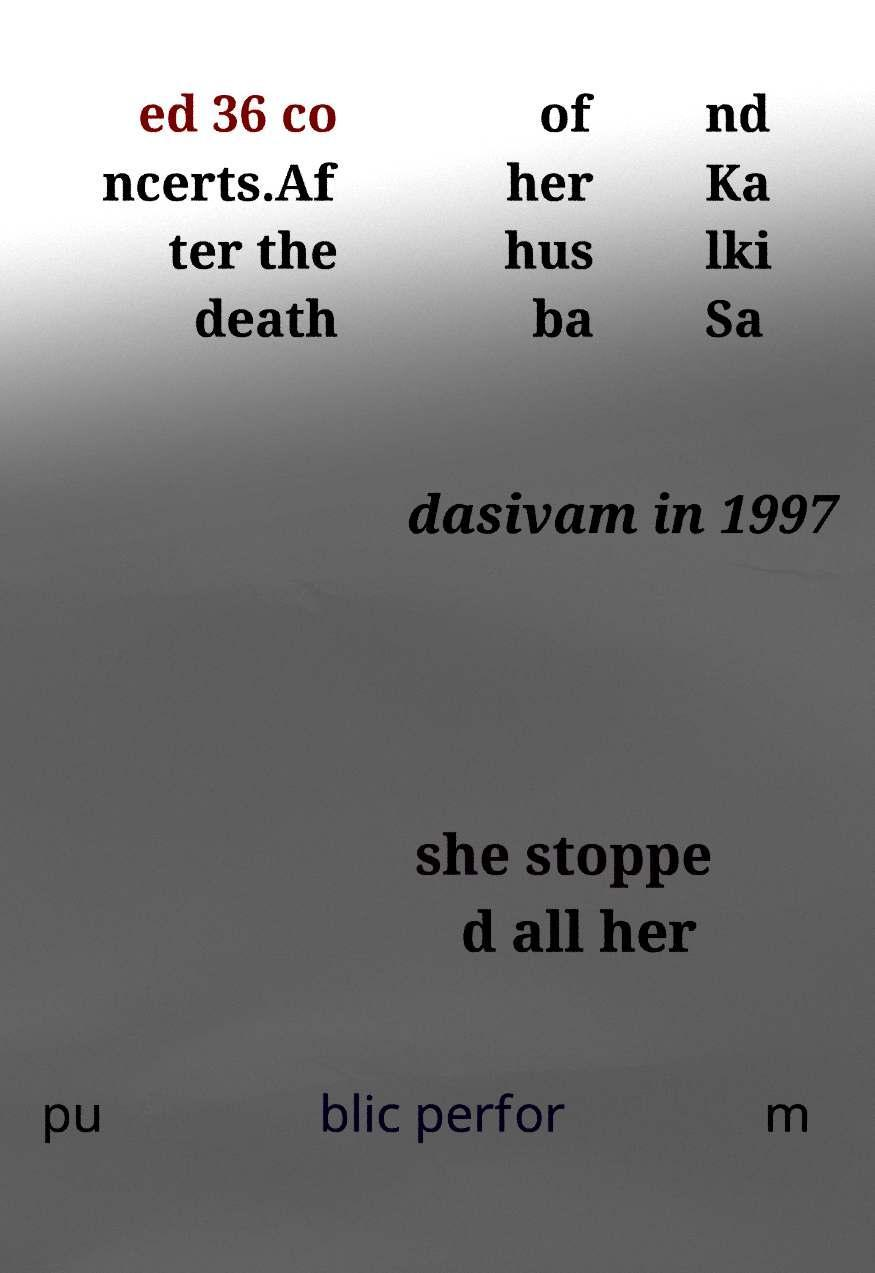Can you read and provide the text displayed in the image?This photo seems to have some interesting text. Can you extract and type it out for me? ed 36 co ncerts.Af ter the death of her hus ba nd Ka lki Sa dasivam in 1997 she stoppe d all her pu blic perfor m 